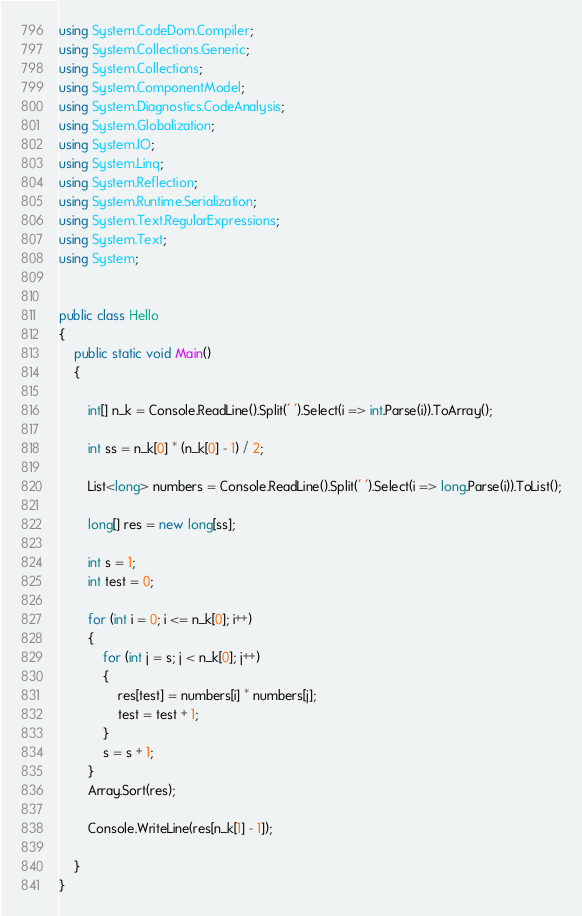Convert code to text. <code><loc_0><loc_0><loc_500><loc_500><_C#_>using System.CodeDom.Compiler;
using System.Collections.Generic;
using System.Collections;
using System.ComponentModel;
using System.Diagnostics.CodeAnalysis;
using System.Globalization;
using System.IO;
using System.Linq;
using System.Reflection;
using System.Runtime.Serialization;
using System.Text.RegularExpressions;
using System.Text;
using System;


public class Hello
{
    public static void Main()
    {

        int[] n_k = Console.ReadLine().Split(' ').Select(i => int.Parse(i)).ToArray();

        int ss = n_k[0] * (n_k[0] - 1) / 2;

        List<long> numbers = Console.ReadLine().Split(' ').Select(i => long.Parse(i)).ToList();
        
        long[] res = new long[ss];

        int s = 1;
        int test = 0;

        for (int i = 0; i <= n_k[0]; i++)
        {
            for (int j = s; j < n_k[0]; j++)
            {
                res[test] = numbers[i] * numbers[j];
                test = test + 1;
            }
            s = s + 1;
        }
        Array.Sort(res);

        Console.WriteLine(res[n_k[1] - 1]);

    }
}</code> 